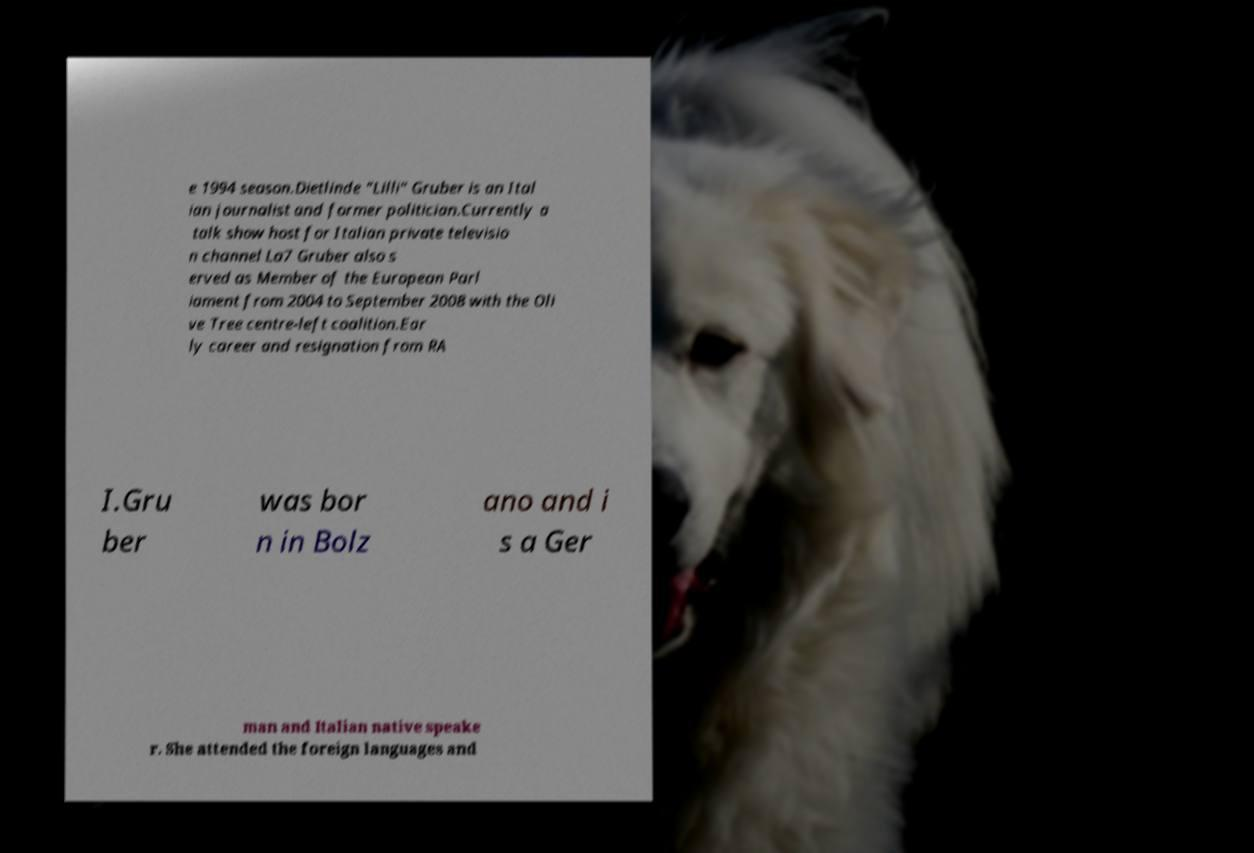What messages or text are displayed in this image? I need them in a readable, typed format. e 1994 season.Dietlinde "Lilli" Gruber is an Ital ian journalist and former politician.Currently a talk show host for Italian private televisio n channel La7 Gruber also s erved as Member of the European Parl iament from 2004 to September 2008 with the Oli ve Tree centre-left coalition.Ear ly career and resignation from RA I.Gru ber was bor n in Bolz ano and i s a Ger man and Italian native speake r. She attended the foreign languages and 